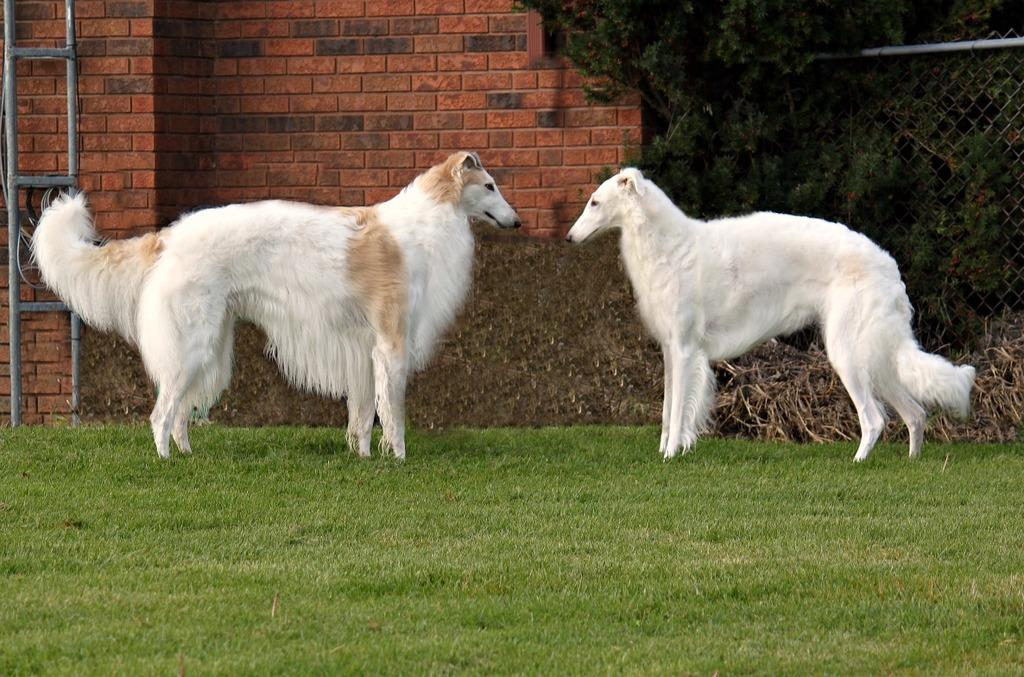How many dogs are in the image? There are two white dogs in the image. What is the position of the dogs in relation to each other? The dogs are standing opposite to each other. What is located behind the dogs? There is a fencing behind the dogs. What is behind the fencing? There is a brick wall behind the fencing. What can be seen beyond the brick wall? Trees are visible behind the fencing and brick wall. How many faucets are visible in the image? There are no faucets visible in the image. What force is being exerted by the dogs in the image? The dogs are not exerting any force in the image; they are standing still. 